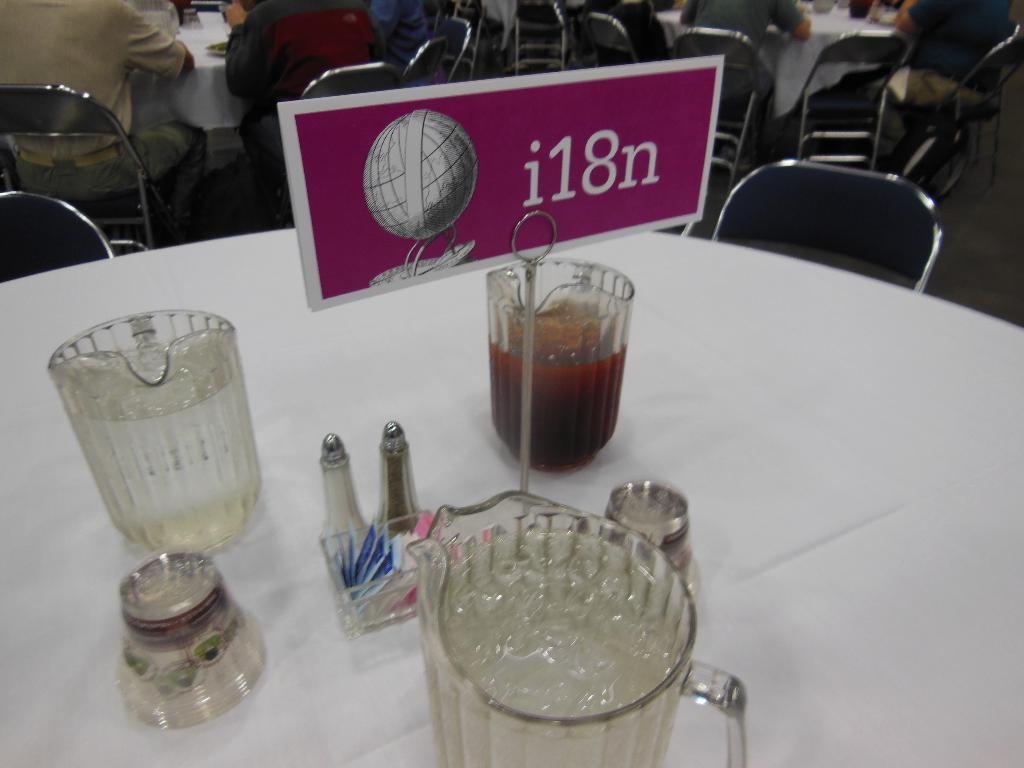Provide a one-sentence caption for the provided image. a conference table with the sign for i18n on it. 